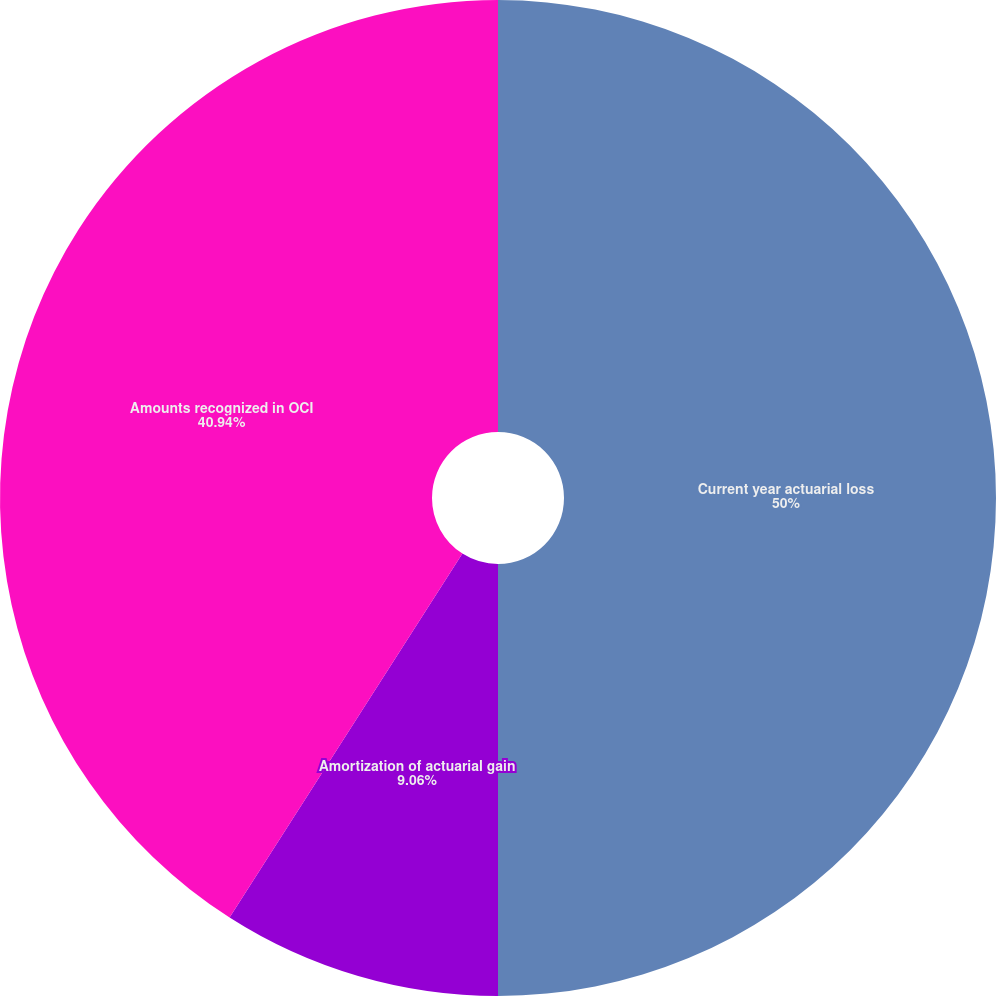<chart> <loc_0><loc_0><loc_500><loc_500><pie_chart><fcel>Current year actuarial loss<fcel>Amortization of actuarial gain<fcel>Amounts recognized in OCI<nl><fcel>50.0%<fcel>9.06%<fcel>40.94%<nl></chart> 